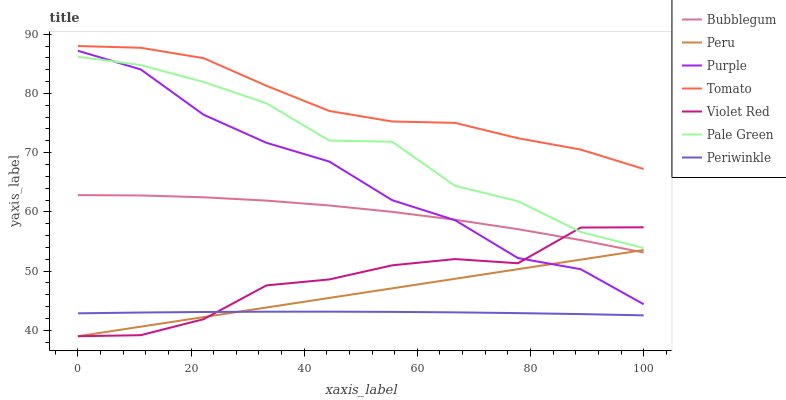Does Periwinkle have the minimum area under the curve?
Answer yes or no. Yes. Does Tomato have the maximum area under the curve?
Answer yes or no. Yes. Does Violet Red have the minimum area under the curve?
Answer yes or no. No. Does Violet Red have the maximum area under the curve?
Answer yes or no. No. Is Peru the smoothest?
Answer yes or no. Yes. Is Pale Green the roughest?
Answer yes or no. Yes. Is Violet Red the smoothest?
Answer yes or no. No. Is Violet Red the roughest?
Answer yes or no. No. Does Violet Red have the lowest value?
Answer yes or no. Yes. Does Purple have the lowest value?
Answer yes or no. No. Does Tomato have the highest value?
Answer yes or no. Yes. Does Violet Red have the highest value?
Answer yes or no. No. Is Purple less than Tomato?
Answer yes or no. Yes. Is Tomato greater than Pale Green?
Answer yes or no. Yes. Does Purple intersect Bubblegum?
Answer yes or no. Yes. Is Purple less than Bubblegum?
Answer yes or no. No. Is Purple greater than Bubblegum?
Answer yes or no. No. Does Purple intersect Tomato?
Answer yes or no. No. 